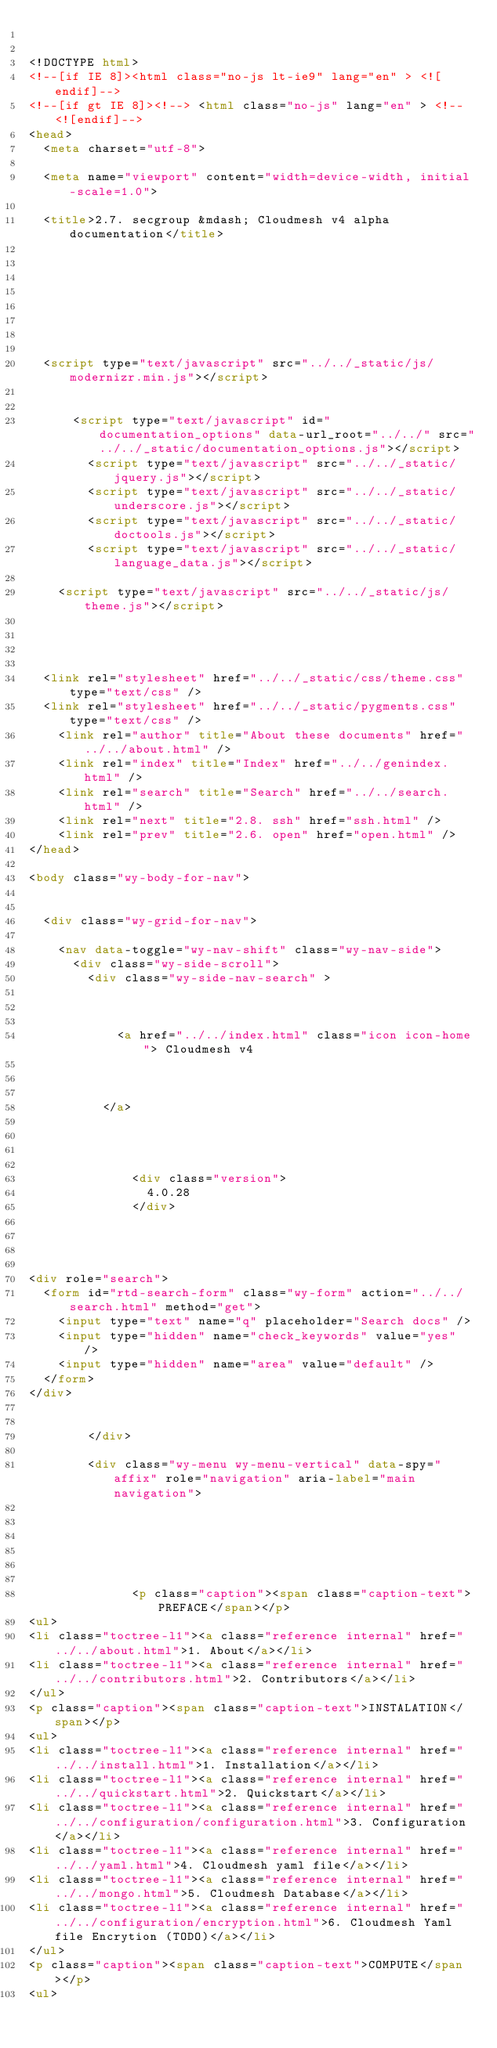Convert code to text. <code><loc_0><loc_0><loc_500><loc_500><_HTML_>

<!DOCTYPE html>
<!--[if IE 8]><html class="no-js lt-ie9" lang="en" > <![endif]-->
<!--[if gt IE 8]><!--> <html class="no-js" lang="en" > <!--<![endif]-->
<head>
  <meta charset="utf-8">
  
  <meta name="viewport" content="width=device-width, initial-scale=1.0">
  
  <title>2.7. secgroup &mdash; Cloudmesh v4 alpha documentation</title>
  

  
  
  
  

  
  <script type="text/javascript" src="../../_static/js/modernizr.min.js"></script>
  
    
      <script type="text/javascript" id="documentation_options" data-url_root="../../" src="../../_static/documentation_options.js"></script>
        <script type="text/javascript" src="../../_static/jquery.js"></script>
        <script type="text/javascript" src="../../_static/underscore.js"></script>
        <script type="text/javascript" src="../../_static/doctools.js"></script>
        <script type="text/javascript" src="../../_static/language_data.js"></script>
    
    <script type="text/javascript" src="../../_static/js/theme.js"></script>

    

  
  <link rel="stylesheet" href="../../_static/css/theme.css" type="text/css" />
  <link rel="stylesheet" href="../../_static/pygments.css" type="text/css" />
    <link rel="author" title="About these documents" href="../../about.html" />
    <link rel="index" title="Index" href="../../genindex.html" />
    <link rel="search" title="Search" href="../../search.html" />
    <link rel="next" title="2.8. ssh" href="ssh.html" />
    <link rel="prev" title="2.6. open" href="open.html" /> 
</head>

<body class="wy-body-for-nav">

   
  <div class="wy-grid-for-nav">
    
    <nav data-toggle="wy-nav-shift" class="wy-nav-side">
      <div class="wy-side-scroll">
        <div class="wy-side-nav-search" >
          

          
            <a href="../../index.html" class="icon icon-home"> Cloudmesh v4
          

          
          </a>

          
            
            
              <div class="version">
                4.0.28
              </div>
            
          

          
<div role="search">
  <form id="rtd-search-form" class="wy-form" action="../../search.html" method="get">
    <input type="text" name="q" placeholder="Search docs" />
    <input type="hidden" name="check_keywords" value="yes" />
    <input type="hidden" name="area" value="default" />
  </form>
</div>

          
        </div>

        <div class="wy-menu wy-menu-vertical" data-spy="affix" role="navigation" aria-label="main navigation">
          
            
            
              
            
            
              <p class="caption"><span class="caption-text">PREFACE</span></p>
<ul>
<li class="toctree-l1"><a class="reference internal" href="../../about.html">1. About</a></li>
<li class="toctree-l1"><a class="reference internal" href="../../contributors.html">2. Contributors</a></li>
</ul>
<p class="caption"><span class="caption-text">INSTALATION</span></p>
<ul>
<li class="toctree-l1"><a class="reference internal" href="../../install.html">1. Installation</a></li>
<li class="toctree-l1"><a class="reference internal" href="../../quickstart.html">2. Quickstart</a></li>
<li class="toctree-l1"><a class="reference internal" href="../../configuration/configuration.html">3. Configuration</a></li>
<li class="toctree-l1"><a class="reference internal" href="../../yaml.html">4. Cloudmesh yaml file</a></li>
<li class="toctree-l1"><a class="reference internal" href="../../mongo.html">5. Cloudmesh Database</a></li>
<li class="toctree-l1"><a class="reference internal" href="../../configuration/encryption.html">6. Cloudmesh Yaml file Encrytion (TODO)</a></li>
</ul>
<p class="caption"><span class="caption-text">COMPUTE</span></p>
<ul></code> 